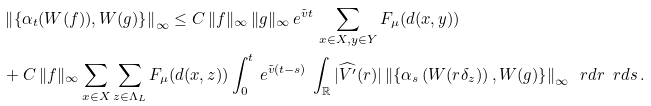<formula> <loc_0><loc_0><loc_500><loc_500>& \left \| \left \{ \alpha _ { t } ( W ( f ) ) , W ( g ) \right \} \right \| _ { \infty } \leq C \, \| f \| _ { \infty } \, \| g \| _ { \infty } \, e ^ { \tilde { v } t } \, \sum _ { x \in X , y \in Y } F _ { \mu } ( d ( x , y ) ) \\ & + C \, \| f \| _ { \infty } \sum _ { x \in X } \sum _ { z \in \Lambda _ { L } } F _ { \mu } ( d ( x , z ) ) \int _ { 0 } ^ { t } \, e ^ { \tilde { v } ( t - s ) } \, \int _ { \mathbb { R } } | \widehat { V ^ { \prime } } ( r ) | \left \| \left \{ \alpha _ { s } \left ( W ( r \delta _ { z } ) \right ) , W ( g ) \right \} \right \| _ { \infty } \, \ r d r \, \ r d s \, .</formula> 